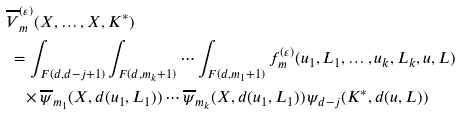<formula> <loc_0><loc_0><loc_500><loc_500>& \overline { V } _ { m } ^ { ( \varepsilon ) } ( X , \dots , X , K ^ { * } ) \\ & \ = \int _ { F ( d , d - j + 1 ) } \int _ { F ( d , m _ { k } + 1 ) } \cdots \int _ { F ( d , m _ { 1 } + 1 ) } f _ { m } ^ { ( \varepsilon ) } ( u _ { 1 } , L _ { 1 } , \dots , u _ { k } , L _ { k } , u , L ) \\ & \quad \times \overline { \psi } _ { m _ { 1 } } ( X , d ( u _ { 1 } , L _ { 1 } ) ) \cdots \overline { \psi } _ { m _ { k } } ( X , d ( u _ { 1 } , L _ { 1 } ) ) \, \psi _ { d - j } ( K ^ { * } , d ( u , L ) )</formula> 